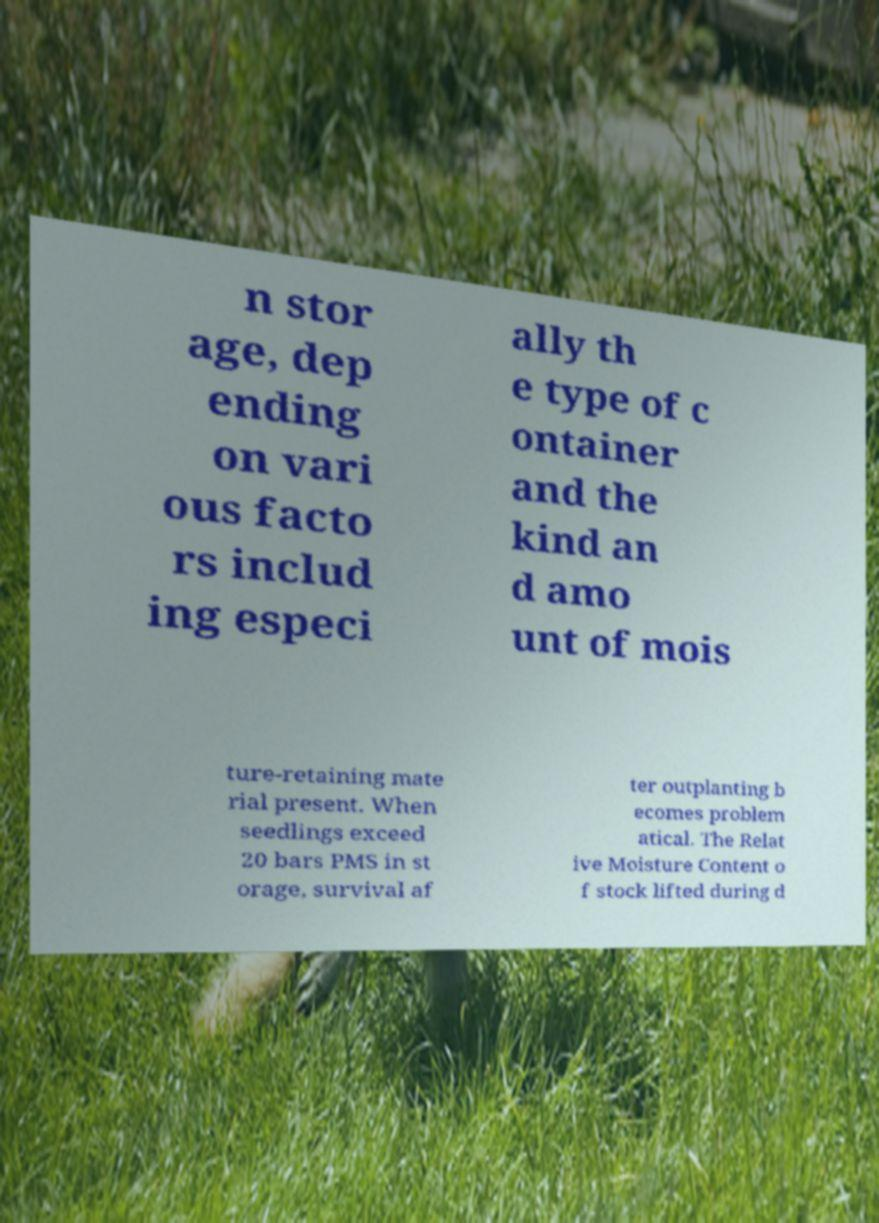What messages or text are displayed in this image? I need them in a readable, typed format. n stor age, dep ending on vari ous facto rs includ ing especi ally th e type of c ontainer and the kind an d amo unt of mois ture-retaining mate rial present. When seedlings exceed 20 bars PMS in st orage, survival af ter outplanting b ecomes problem atical. The Relat ive Moisture Content o f stock lifted during d 